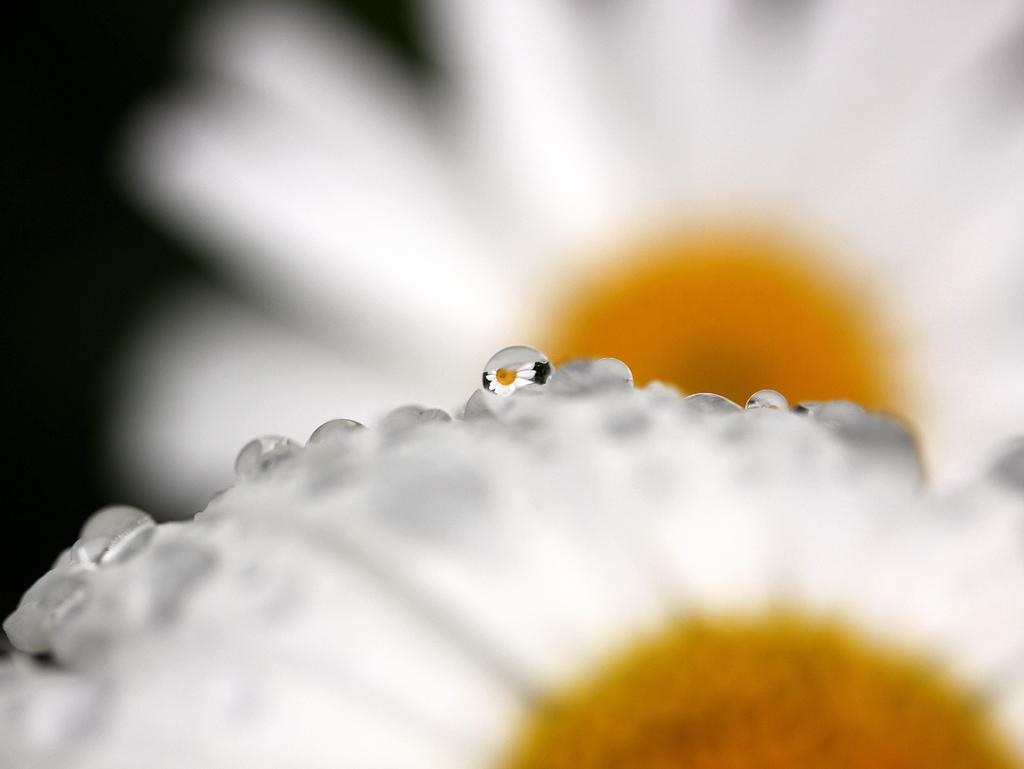What type of flowers can be seen in the image? There are two white color flowers in the image. Where are the flowers located in the image? The flowers are in the front of the image. What can be observed about the background of the image? The background of the image is blurry. What type of expert advice can be given about the activity depicted in the image? There is no activity depicted in the image, as it only features two white color flowers in the front with a blurry background. 